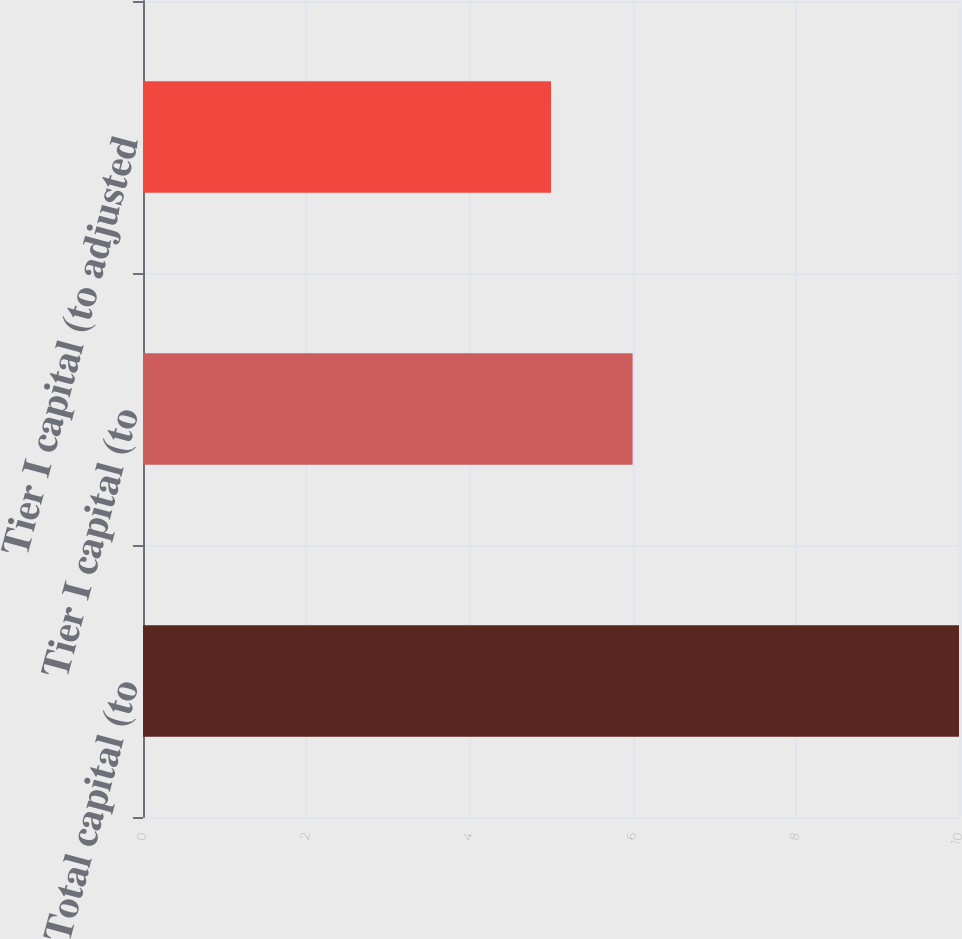Convert chart. <chart><loc_0><loc_0><loc_500><loc_500><bar_chart><fcel>Total capital (to<fcel>Tier I capital (to<fcel>Tier I capital (to adjusted<nl><fcel>10<fcel>6<fcel>5<nl></chart> 